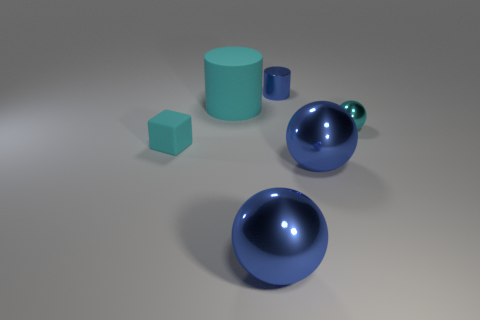Subtract all blue balls. How many balls are left? 1 Subtract all yellow blocks. How many blue spheres are left? 2 Add 3 large yellow rubber spheres. How many objects exist? 9 Subtract all purple spheres. Subtract all brown cylinders. How many spheres are left? 3 Subtract all blocks. How many objects are left? 5 Subtract all large yellow metallic cylinders. Subtract all large cyan things. How many objects are left? 5 Add 6 balls. How many balls are left? 9 Add 4 matte blocks. How many matte blocks exist? 5 Subtract 0 purple blocks. How many objects are left? 6 